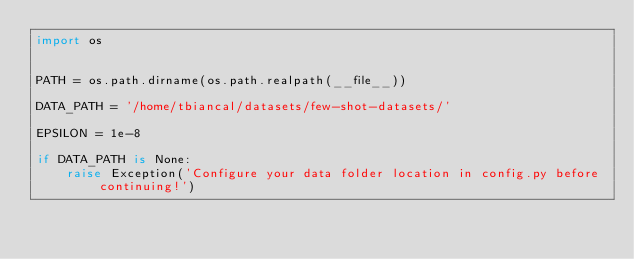Convert code to text. <code><loc_0><loc_0><loc_500><loc_500><_Python_>import os


PATH = os.path.dirname(os.path.realpath(__file__))

DATA_PATH = '/home/tbiancal/datasets/few-shot-datasets/'

EPSILON = 1e-8

if DATA_PATH is None:
    raise Exception('Configure your data folder location in config.py before continuing!')
</code> 